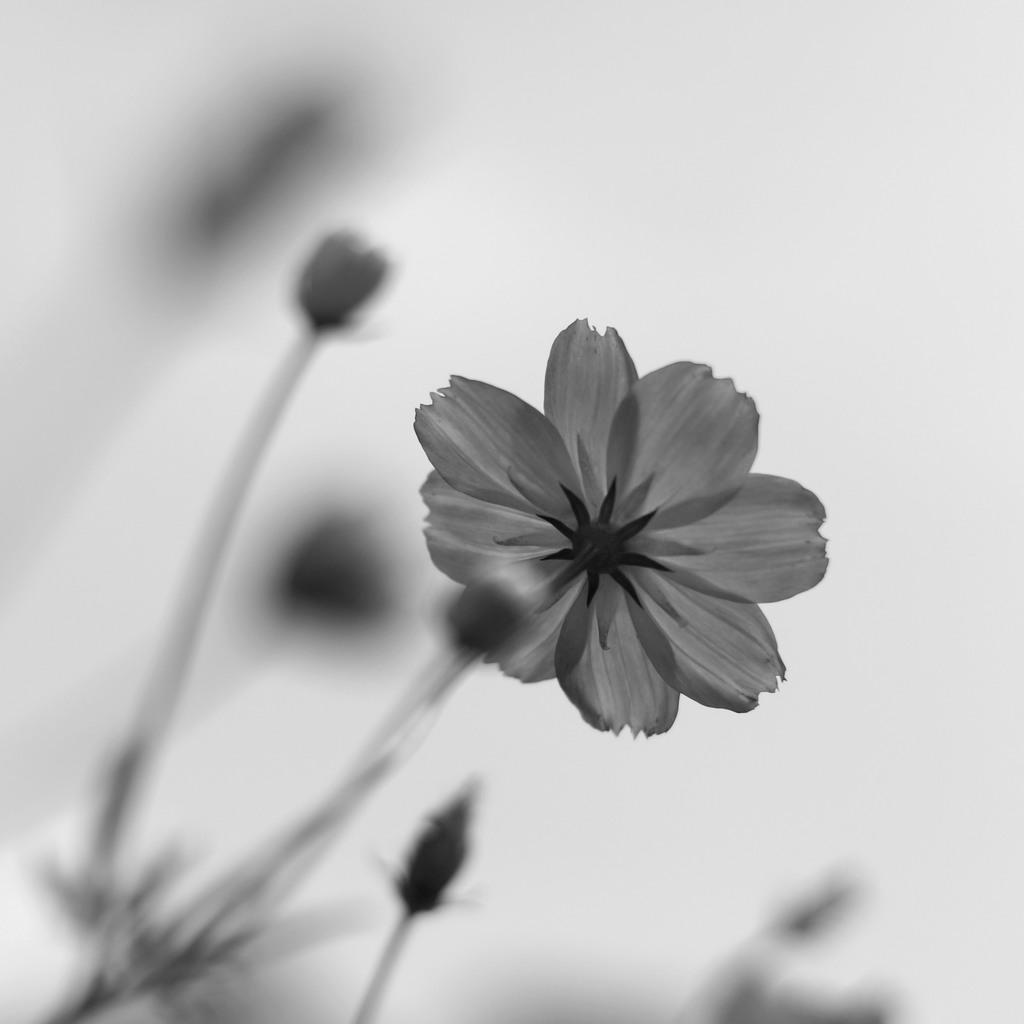What is the color scheme of the image? The image is black and white. What is the main subject in the foreground of the image? There is a flower in the front of the image. How would you describe the background of the image? The background of the image is blurry. What type of poison is hidden in the verse on the flower in the image? There is no verse or poison present in the image; it features a black and white flower with a blurry background. 